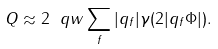Convert formula to latex. <formula><loc_0><loc_0><loc_500><loc_500>Q \approx 2 \ q w \sum _ { f } | q _ { f } | \gamma ( 2 | q _ { f } \Phi | ) .</formula> 